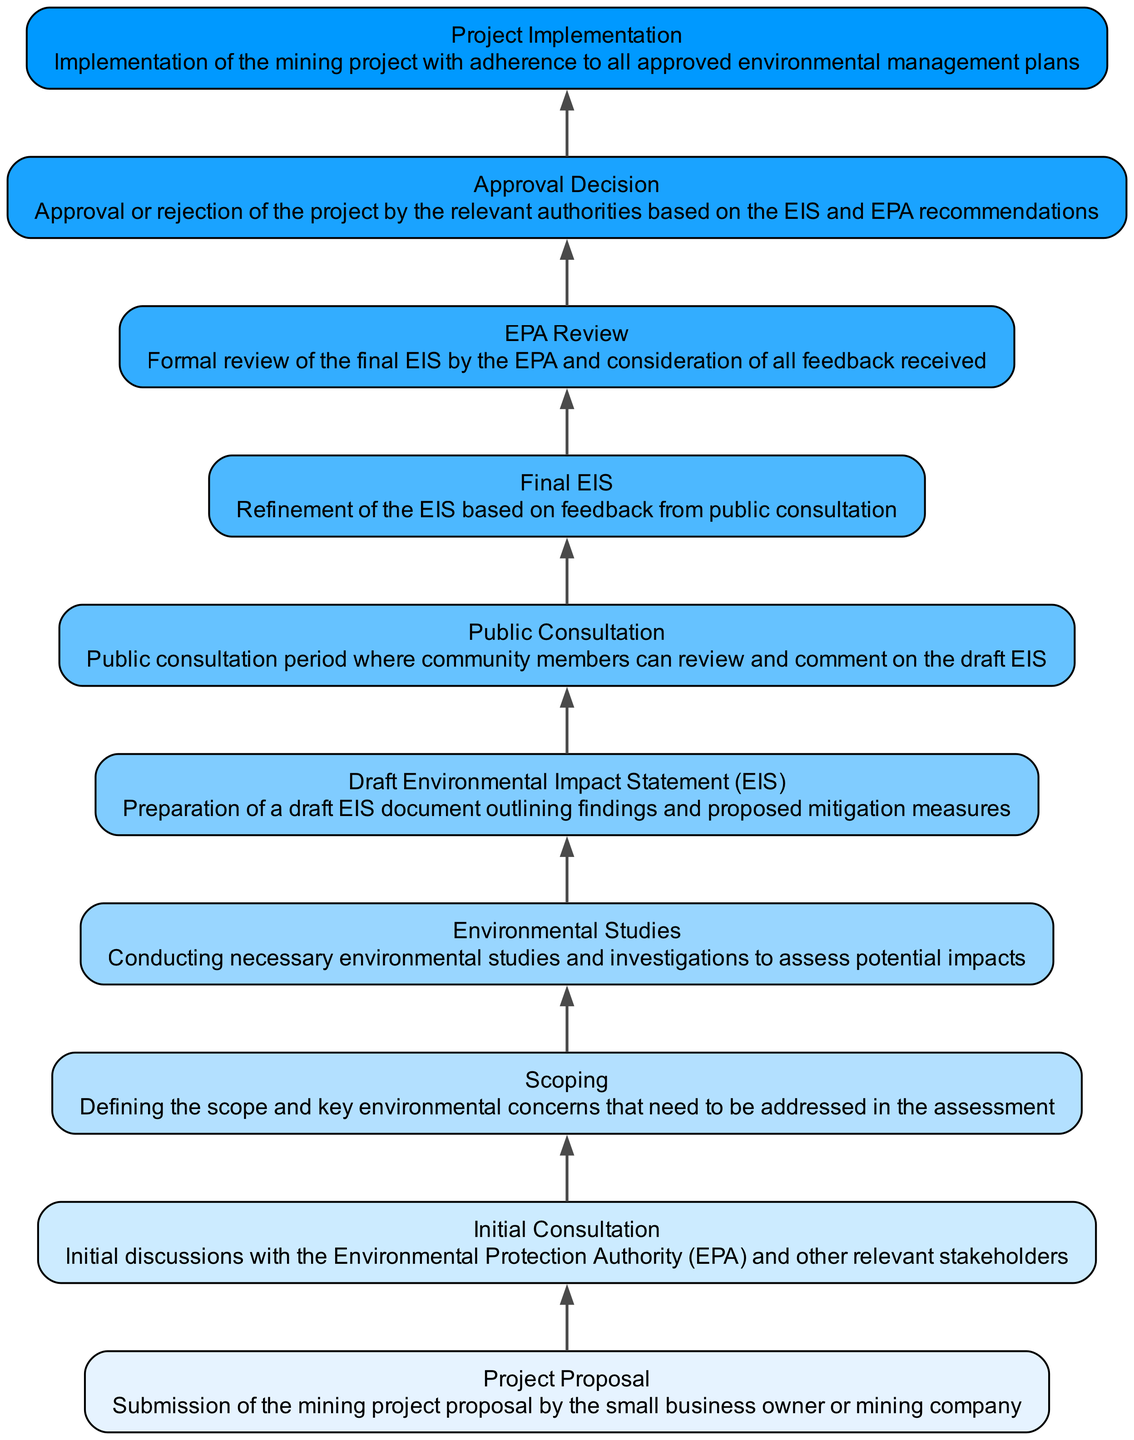What is the first step in the process? The first step, according to the diagram, is the "Project Proposal" where the mining project proposal is submitted.
Answer: Project Proposal How many nodes are in the diagram? By counting the elements provided, there are a total of 10 nodes in the diagram.
Answer: 10 What happens after the "Scoping"? After "Scoping," the next step is "Environmental Studies," indicating that studies are conducted following the scoping of environmental concerns.
Answer: Environmental Studies What is the last step in the process? The last step, as indicated by the diagram, is "Project Implementation," which involves the actual implementation of the mining project.
Answer: Project Implementation Which step has a public component? The "Public Consultation" step has a public component where community members can review and comment on the draft EIS.
Answer: Public Consultation Which process follows the "Initial Consultation"? Following the "Initial Consultation," the next step is "Scoping," where the scope and key concerns are defined.
Answer: Scoping What step occurs immediately before "Approval Decision"? The step that occurs immediately before "Approval Decision" is "EPA Review," where the final EIS is reviewed by the EPA.
Answer: EPA Review What is the purpose of the "Draft Environmental Impact Statement (EIS)"? The purpose of the "Draft EIS" is to outline findings and proposed mitigation measures following the environmental studies.
Answer: Outline findings and proposed mitigation measures What is the connection between "Environmental Studies" and "Final EIS"? "Final EIS" is derived from the findings of the "Environmental Studies" and includes refinements based on feedback from public consultation.
Answer: Refinements based on feedback What is required for project implementation? Project implementation requires adherence to all approved environmental management plans as outlined in the EIS.
Answer: Adherence to approved environmental management plans 